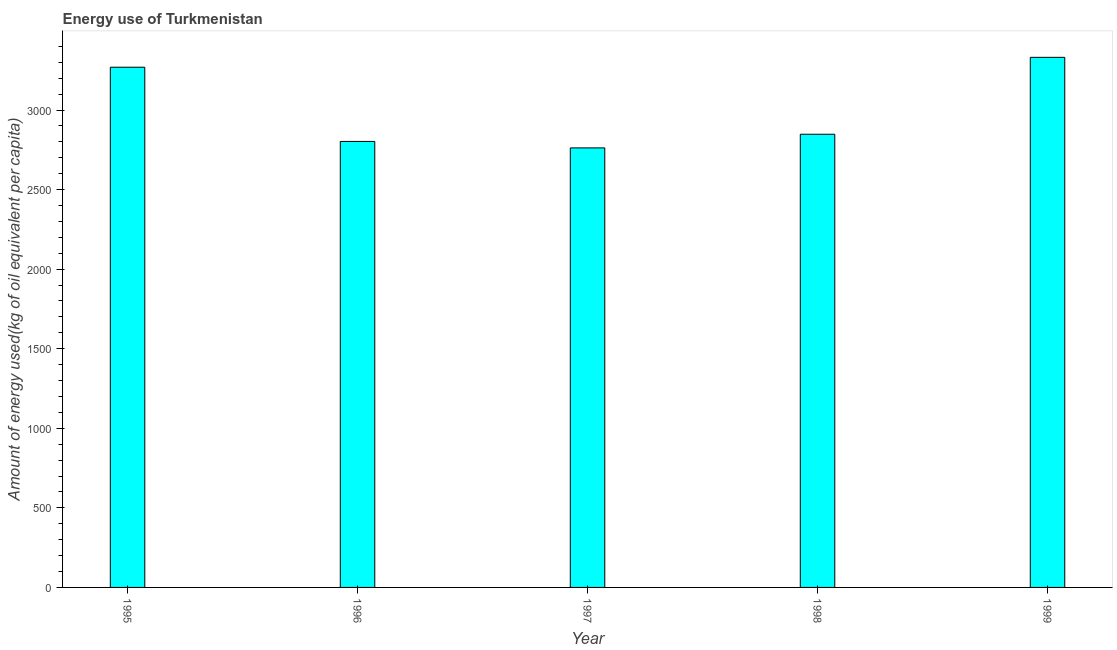Does the graph contain grids?
Provide a succinct answer. No. What is the title of the graph?
Your answer should be very brief. Energy use of Turkmenistan. What is the label or title of the X-axis?
Provide a short and direct response. Year. What is the label or title of the Y-axis?
Your response must be concise. Amount of energy used(kg of oil equivalent per capita). What is the amount of energy used in 1995?
Make the answer very short. 3269.22. Across all years, what is the maximum amount of energy used?
Give a very brief answer. 3331.28. Across all years, what is the minimum amount of energy used?
Make the answer very short. 2762.15. In which year was the amount of energy used maximum?
Your answer should be very brief. 1999. What is the sum of the amount of energy used?
Ensure brevity in your answer.  1.50e+04. What is the difference between the amount of energy used in 1998 and 1999?
Provide a succinct answer. -483.38. What is the average amount of energy used per year?
Give a very brief answer. 3002.66. What is the median amount of energy used?
Offer a very short reply. 2847.9. What is the ratio of the amount of energy used in 1995 to that in 1997?
Your answer should be compact. 1.18. Is the difference between the amount of energy used in 1995 and 1998 greater than the difference between any two years?
Provide a short and direct response. No. What is the difference between the highest and the second highest amount of energy used?
Make the answer very short. 62.06. What is the difference between the highest and the lowest amount of energy used?
Your answer should be compact. 569.13. How many bars are there?
Keep it short and to the point. 5. How many years are there in the graph?
Your answer should be very brief. 5. Are the values on the major ticks of Y-axis written in scientific E-notation?
Provide a succinct answer. No. What is the Amount of energy used(kg of oil equivalent per capita) of 1995?
Keep it short and to the point. 3269.22. What is the Amount of energy used(kg of oil equivalent per capita) of 1996?
Ensure brevity in your answer.  2802.75. What is the Amount of energy used(kg of oil equivalent per capita) in 1997?
Provide a short and direct response. 2762.15. What is the Amount of energy used(kg of oil equivalent per capita) of 1998?
Offer a terse response. 2847.9. What is the Amount of energy used(kg of oil equivalent per capita) of 1999?
Offer a very short reply. 3331.28. What is the difference between the Amount of energy used(kg of oil equivalent per capita) in 1995 and 1996?
Keep it short and to the point. 466.46. What is the difference between the Amount of energy used(kg of oil equivalent per capita) in 1995 and 1997?
Your answer should be very brief. 507.07. What is the difference between the Amount of energy used(kg of oil equivalent per capita) in 1995 and 1998?
Make the answer very short. 421.32. What is the difference between the Amount of energy used(kg of oil equivalent per capita) in 1995 and 1999?
Keep it short and to the point. -62.06. What is the difference between the Amount of energy used(kg of oil equivalent per capita) in 1996 and 1997?
Keep it short and to the point. 40.61. What is the difference between the Amount of energy used(kg of oil equivalent per capita) in 1996 and 1998?
Make the answer very short. -45.14. What is the difference between the Amount of energy used(kg of oil equivalent per capita) in 1996 and 1999?
Offer a very short reply. -528.52. What is the difference between the Amount of energy used(kg of oil equivalent per capita) in 1997 and 1998?
Offer a terse response. -85.75. What is the difference between the Amount of energy used(kg of oil equivalent per capita) in 1997 and 1999?
Ensure brevity in your answer.  -569.13. What is the difference between the Amount of energy used(kg of oil equivalent per capita) in 1998 and 1999?
Make the answer very short. -483.38. What is the ratio of the Amount of energy used(kg of oil equivalent per capita) in 1995 to that in 1996?
Offer a terse response. 1.17. What is the ratio of the Amount of energy used(kg of oil equivalent per capita) in 1995 to that in 1997?
Offer a very short reply. 1.18. What is the ratio of the Amount of energy used(kg of oil equivalent per capita) in 1995 to that in 1998?
Your answer should be very brief. 1.15. What is the ratio of the Amount of energy used(kg of oil equivalent per capita) in 1995 to that in 1999?
Offer a terse response. 0.98. What is the ratio of the Amount of energy used(kg of oil equivalent per capita) in 1996 to that in 1997?
Your answer should be very brief. 1.01. What is the ratio of the Amount of energy used(kg of oil equivalent per capita) in 1996 to that in 1999?
Give a very brief answer. 0.84. What is the ratio of the Amount of energy used(kg of oil equivalent per capita) in 1997 to that in 1998?
Provide a short and direct response. 0.97. What is the ratio of the Amount of energy used(kg of oil equivalent per capita) in 1997 to that in 1999?
Offer a terse response. 0.83. What is the ratio of the Amount of energy used(kg of oil equivalent per capita) in 1998 to that in 1999?
Your response must be concise. 0.85. 